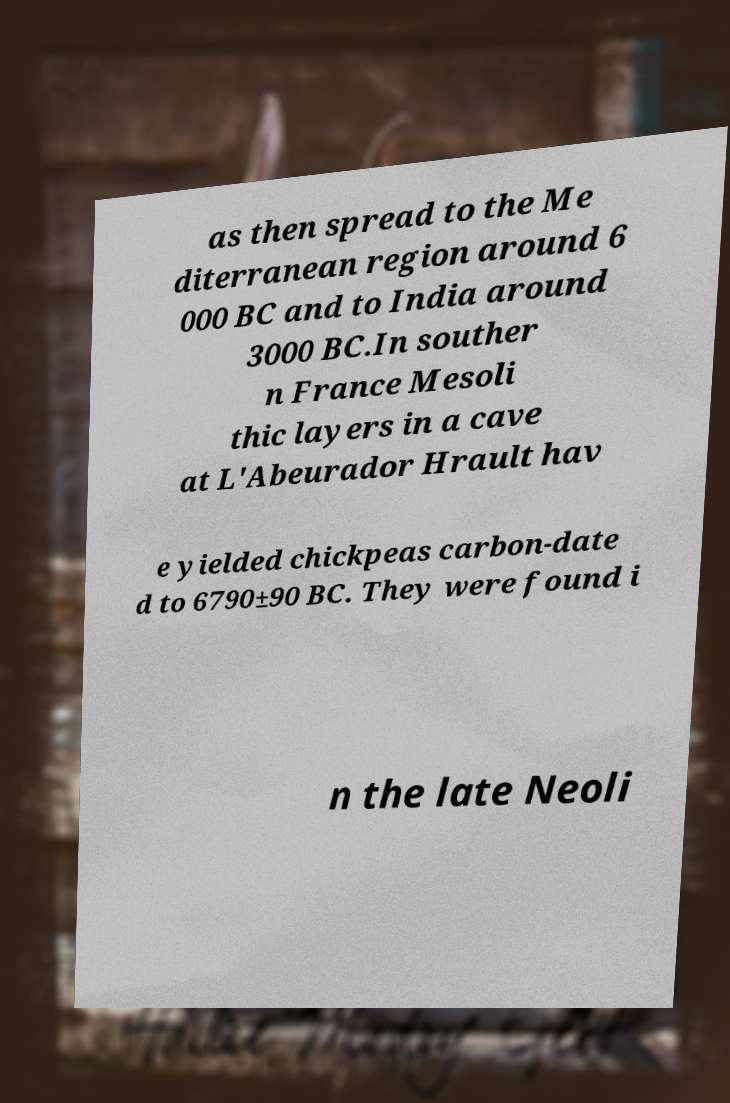There's text embedded in this image that I need extracted. Can you transcribe it verbatim? as then spread to the Me diterranean region around 6 000 BC and to India around 3000 BC.In souther n France Mesoli thic layers in a cave at L'Abeurador Hrault hav e yielded chickpeas carbon-date d to 6790±90 BC. They were found i n the late Neoli 